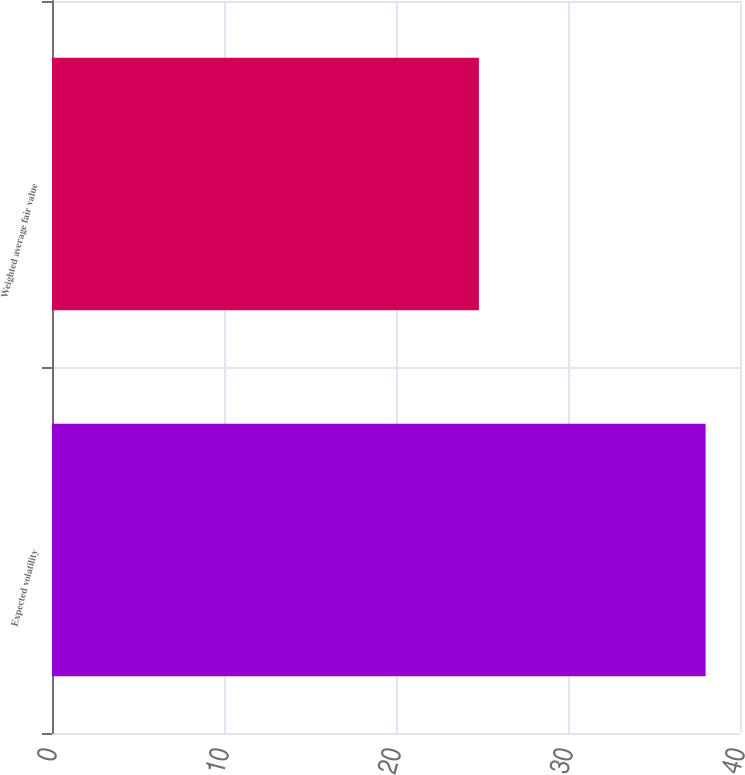Convert chart to OTSL. <chart><loc_0><loc_0><loc_500><loc_500><bar_chart><fcel>Expected volatility<fcel>Weighted average fair value<nl><fcel>38<fcel>24.82<nl></chart> 